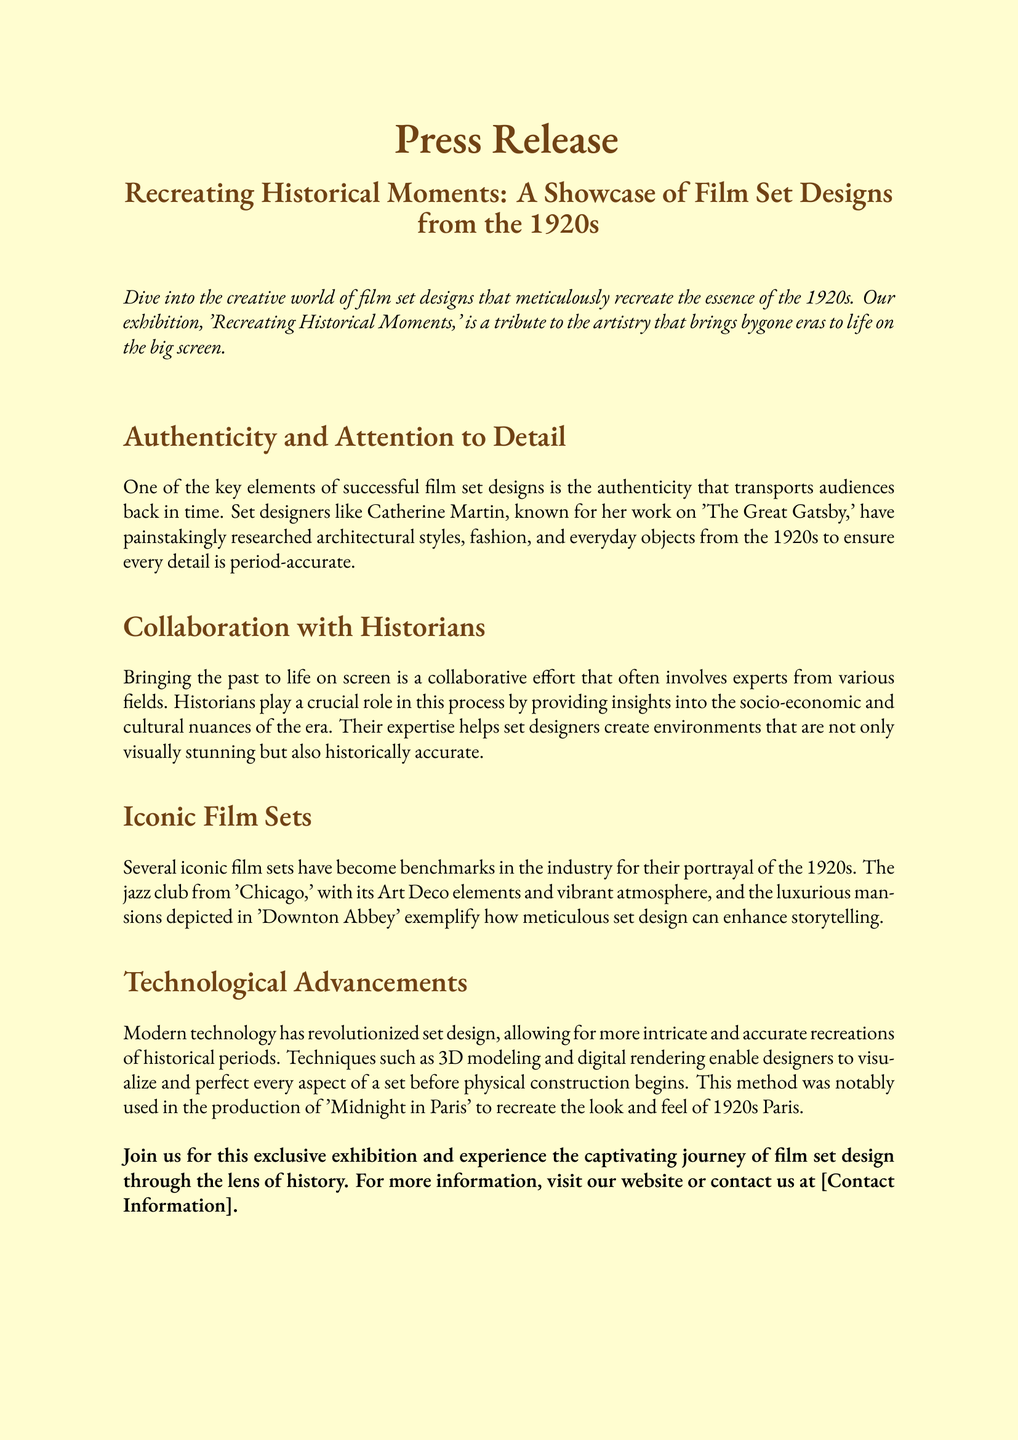What is the title of the exhibition? The title of the exhibition is mentioned at the beginning of the document.
Answer: Recreating Historical Moments: A Showcase of Film Set Designs from the 1920s Who is a notable set designer mentioned in the document? The document highlights a specific set designer known for her work on a famous film.
Answer: Catherine Martin What film is referenced in relation to the jazz club set? The document provides an example of a film that features an iconic set from the 1920s.
Answer: Chicago What technique is mentioned as being used for modern set design? The document discusses a specific method that modern designers employ to enhance set accuracy.
Answer: 3D modeling What architectural style is associated with the iconic film sets from the 1920s? The document refers to a particular design style that characterizes the sets mentioned.
Answer: Art Deco How do historians contribute to film set design? The document explains the role historians play in creating accurate representations of historical periods.
Answer: Providing insights In which film was digital rendering notably used? The document cites a specific film where advanced technology was applied in set design.
Answer: Midnight in Paris What is the purpose of the exhibition? The document states the intention behind showcasing film set designs from a specific era.
Answer: Experience the captivating journey of film set design through the lens of history 